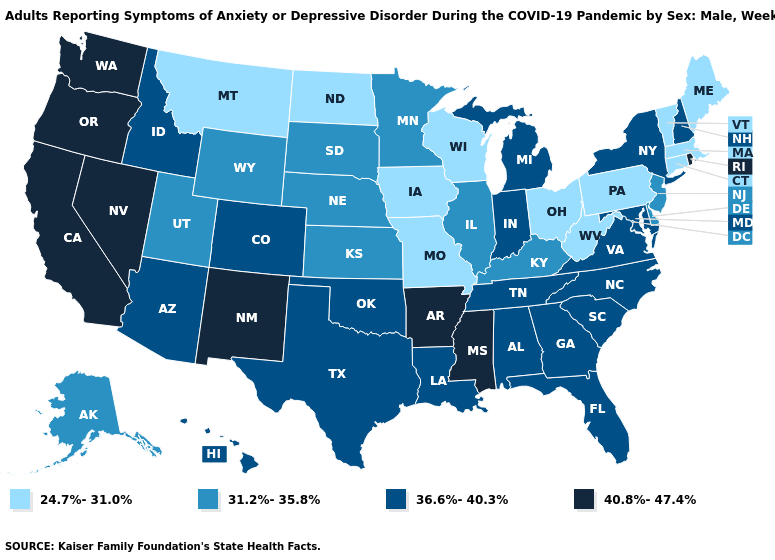Name the states that have a value in the range 40.8%-47.4%?
Keep it brief. Arkansas, California, Mississippi, Nevada, New Mexico, Oregon, Rhode Island, Washington. Does Louisiana have the same value as Rhode Island?
Keep it brief. No. What is the value of Colorado?
Keep it brief. 36.6%-40.3%. Name the states that have a value in the range 40.8%-47.4%?
Short answer required. Arkansas, California, Mississippi, Nevada, New Mexico, Oregon, Rhode Island, Washington. Does Georgia have the same value as Arizona?
Concise answer only. Yes. Name the states that have a value in the range 24.7%-31.0%?
Keep it brief. Connecticut, Iowa, Maine, Massachusetts, Missouri, Montana, North Dakota, Ohio, Pennsylvania, Vermont, West Virginia, Wisconsin. What is the value of Tennessee?
Answer briefly. 36.6%-40.3%. Which states have the lowest value in the USA?
Short answer required. Connecticut, Iowa, Maine, Massachusetts, Missouri, Montana, North Dakota, Ohio, Pennsylvania, Vermont, West Virginia, Wisconsin. What is the value of Massachusetts?
Short answer required. 24.7%-31.0%. Name the states that have a value in the range 40.8%-47.4%?
Quick response, please. Arkansas, California, Mississippi, Nevada, New Mexico, Oregon, Rhode Island, Washington. Which states have the highest value in the USA?
Give a very brief answer. Arkansas, California, Mississippi, Nevada, New Mexico, Oregon, Rhode Island, Washington. Is the legend a continuous bar?
Be succinct. No. Name the states that have a value in the range 40.8%-47.4%?
Concise answer only. Arkansas, California, Mississippi, Nevada, New Mexico, Oregon, Rhode Island, Washington. Does Indiana have the highest value in the USA?
Keep it brief. No. What is the highest value in the West ?
Write a very short answer. 40.8%-47.4%. 